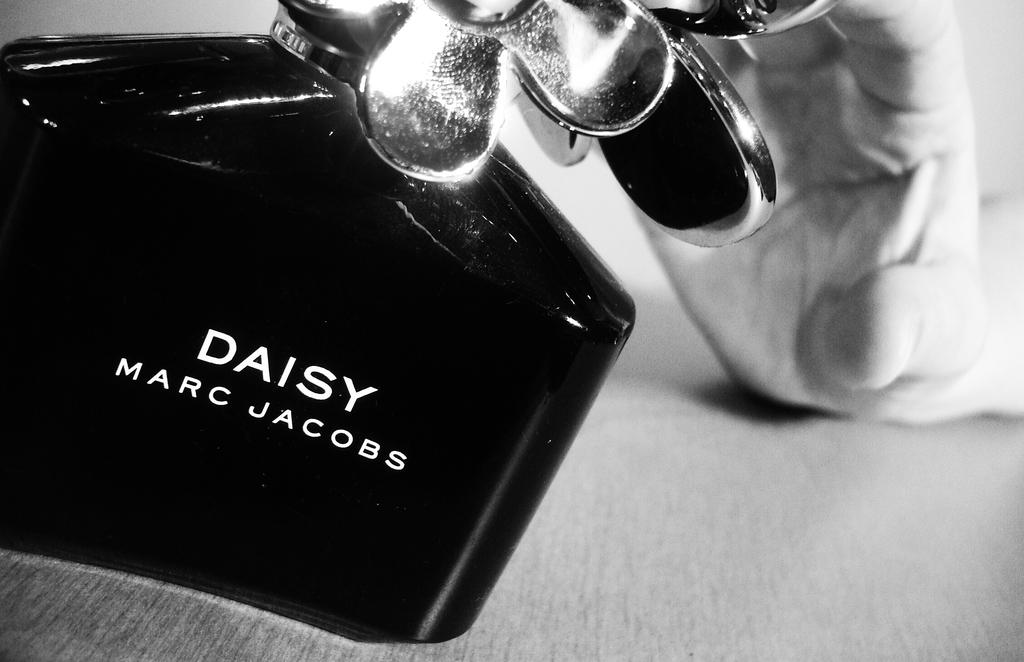Is this a bottle of daisy?
Offer a terse response. Yes. Who makes this perfume?
Provide a succinct answer. Marc jacobs. 